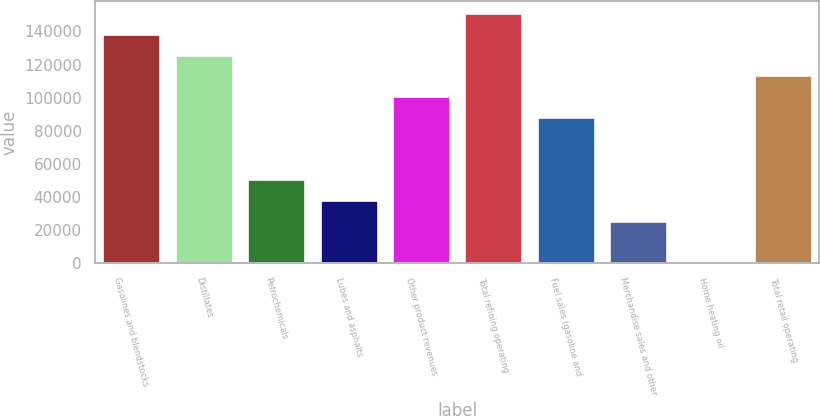Convert chart. <chart><loc_0><loc_0><loc_500><loc_500><bar_chart><fcel>Gasolines and blendstocks<fcel>Distillates<fcel>Petrochemicals<fcel>Lubes and asphalts<fcel>Other product revenues<fcel>Total refining operating<fcel>Fuel sales (gasoline and<fcel>Merchandise sales and other<fcel>Home heating oil<fcel>Total retail operating<nl><fcel>138552<fcel>125987<fcel>50595.2<fcel>38029.9<fcel>100856<fcel>151118<fcel>88291.1<fcel>25464.6<fcel>334<fcel>113422<nl></chart> 